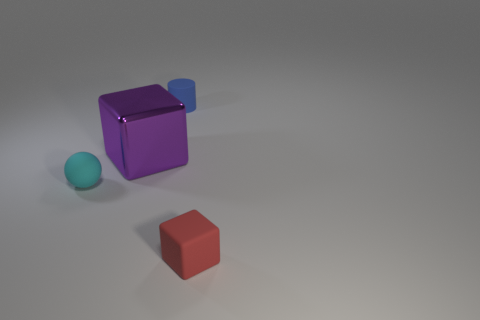Add 3 small cyan rubber balls. How many objects exist? 7 Subtract all spheres. How many objects are left? 3 Subtract all small brown metallic cylinders. Subtract all big shiny things. How many objects are left? 3 Add 2 small rubber spheres. How many small rubber spheres are left? 3 Add 3 tiny brown balls. How many tiny brown balls exist? 3 Subtract 0 brown cubes. How many objects are left? 4 